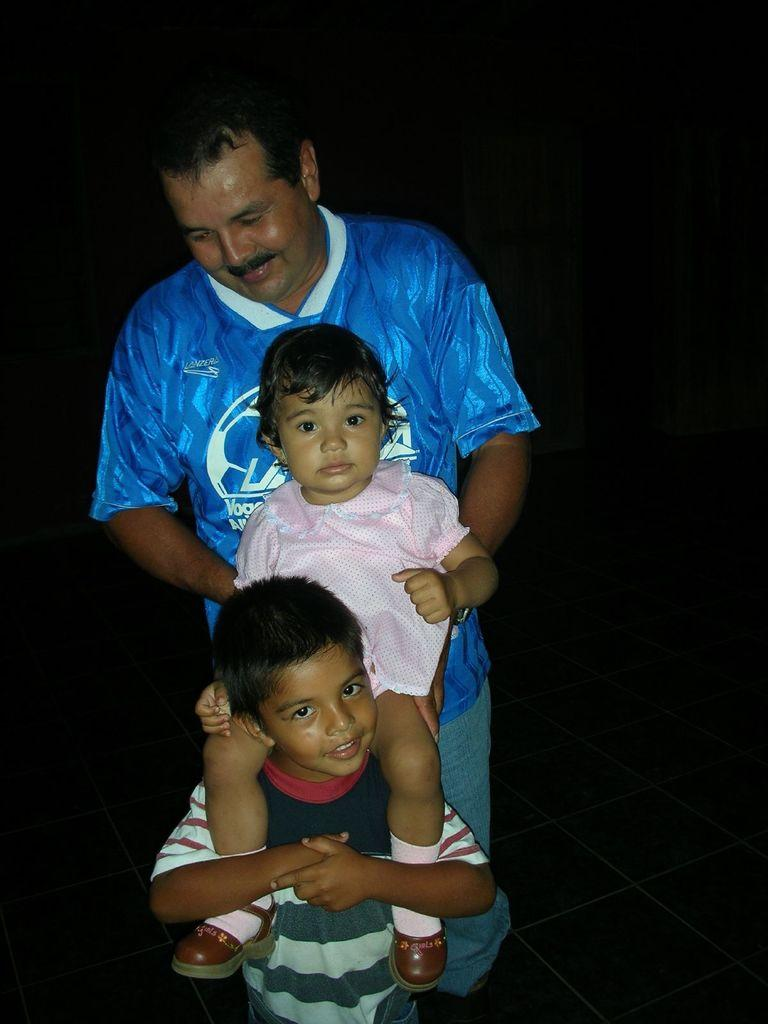How many individuals are present in the image? There are three people in the image. Can you describe the gender of each person? One of the people is a boy, one is a girl, and one is a man. What can be said about the background of the image? The background of the image appears to be dark. Where is the nest located in the image? There is no nest present in the image. Can you tell me how many uncles are in the image? The provided facts do not mention any uncles in the image. What is in the man's pocket in the image? The provided facts do not mention any pockets or items in pockets in the image. 